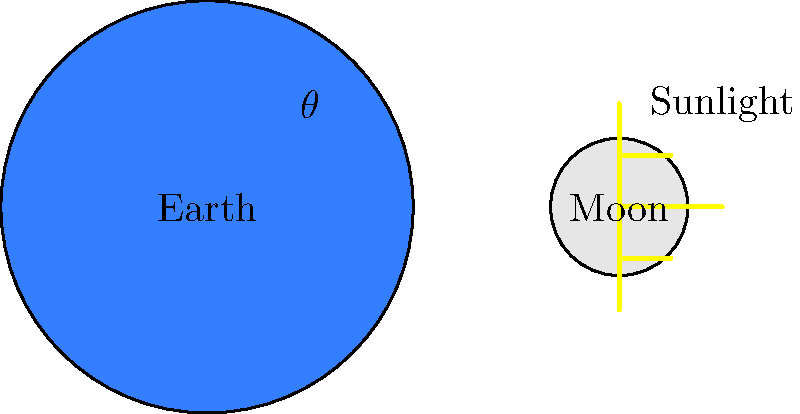As a Catholic living in Capiz, you often observe the night sky and reflect on God's creation. During a parish discussion on astronomy, you're asked to explain the phase of the moon when it forms an angle $\theta$ with respect to the Earth and Sun, as shown in the diagram. What phase would the moon be in, and how does this relate to the lunar calendar used in determining the date of Easter? To answer this question, let's follow these steps:

1. Understand moon phases:
   The moon's phases are determined by the relative positions of the Earth, Moon, and Sun.

2. Analyze the diagram:
   The angle $\theta$ represents the angular separation between the Moon and the Sun as seen from Earth.

3. Determine the phase:
   - When $\theta = 0°$, it's a New Moon (not visible from Earth).
   - When $\theta = 90°$, it's the First Quarter Moon (half illuminated).
   - When $\theta = 180°$, it's a Full Moon (fully illuminated).
   - When $\theta = 270°$, it's the Last Quarter Moon (half illuminated).

4. In this diagram, $\theta$ is approximately 45°, which is between New Moon and First Quarter.
   This phase is called a Waxing Crescent.

5. Relation to the lunar calendar and Easter:
   - The lunar calendar is based on the moon's phases.
   - Easter Sunday falls on the first Sunday after the first Full Moon following the spring equinox.
   - The Waxing Crescent phase occurs about 3-4 days after a New Moon, which is early in the lunar cycle.

6. Catholic significance:
   - The timing of Easter reflects the Paschal mystery, central to the Catholic faith.
   - Observing the moon's phases can serve as a natural way to reflect on the cyclical nature of life and faith.
Answer: Waxing Crescent; precedes the Full Moon used to determine Easter date 